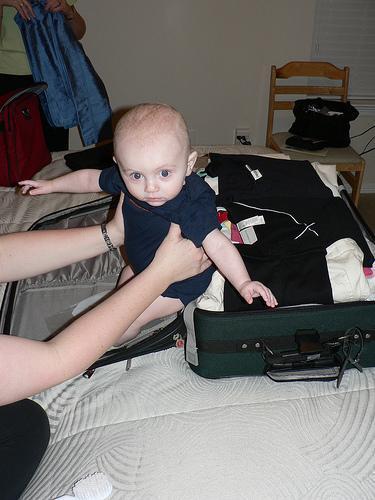How many babies are in the picture?
Give a very brief answer. 1. 